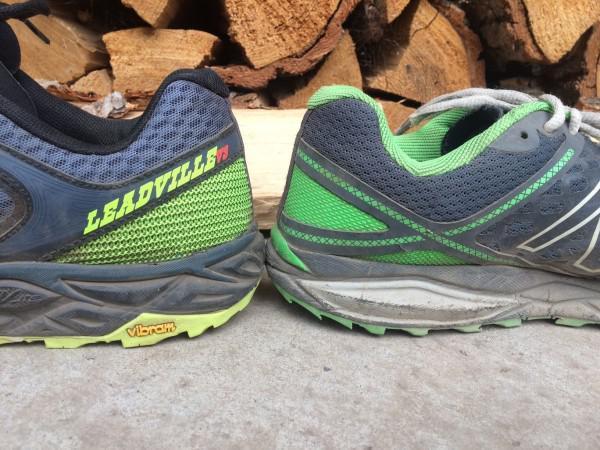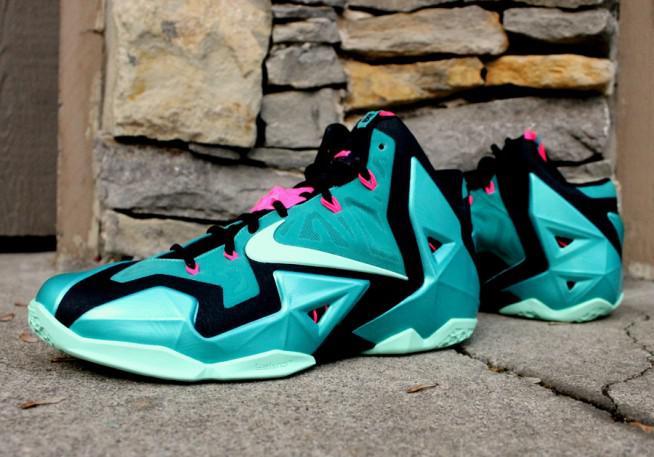The first image is the image on the left, the second image is the image on the right. Given the left and right images, does the statement "The shoes in the left image are facing opposite each other." hold true? Answer yes or no. Yes. The first image is the image on the left, the second image is the image on the right. Examine the images to the left and right. Is the description "shoes are placed heel to heel" accurate? Answer yes or no. Yes. 